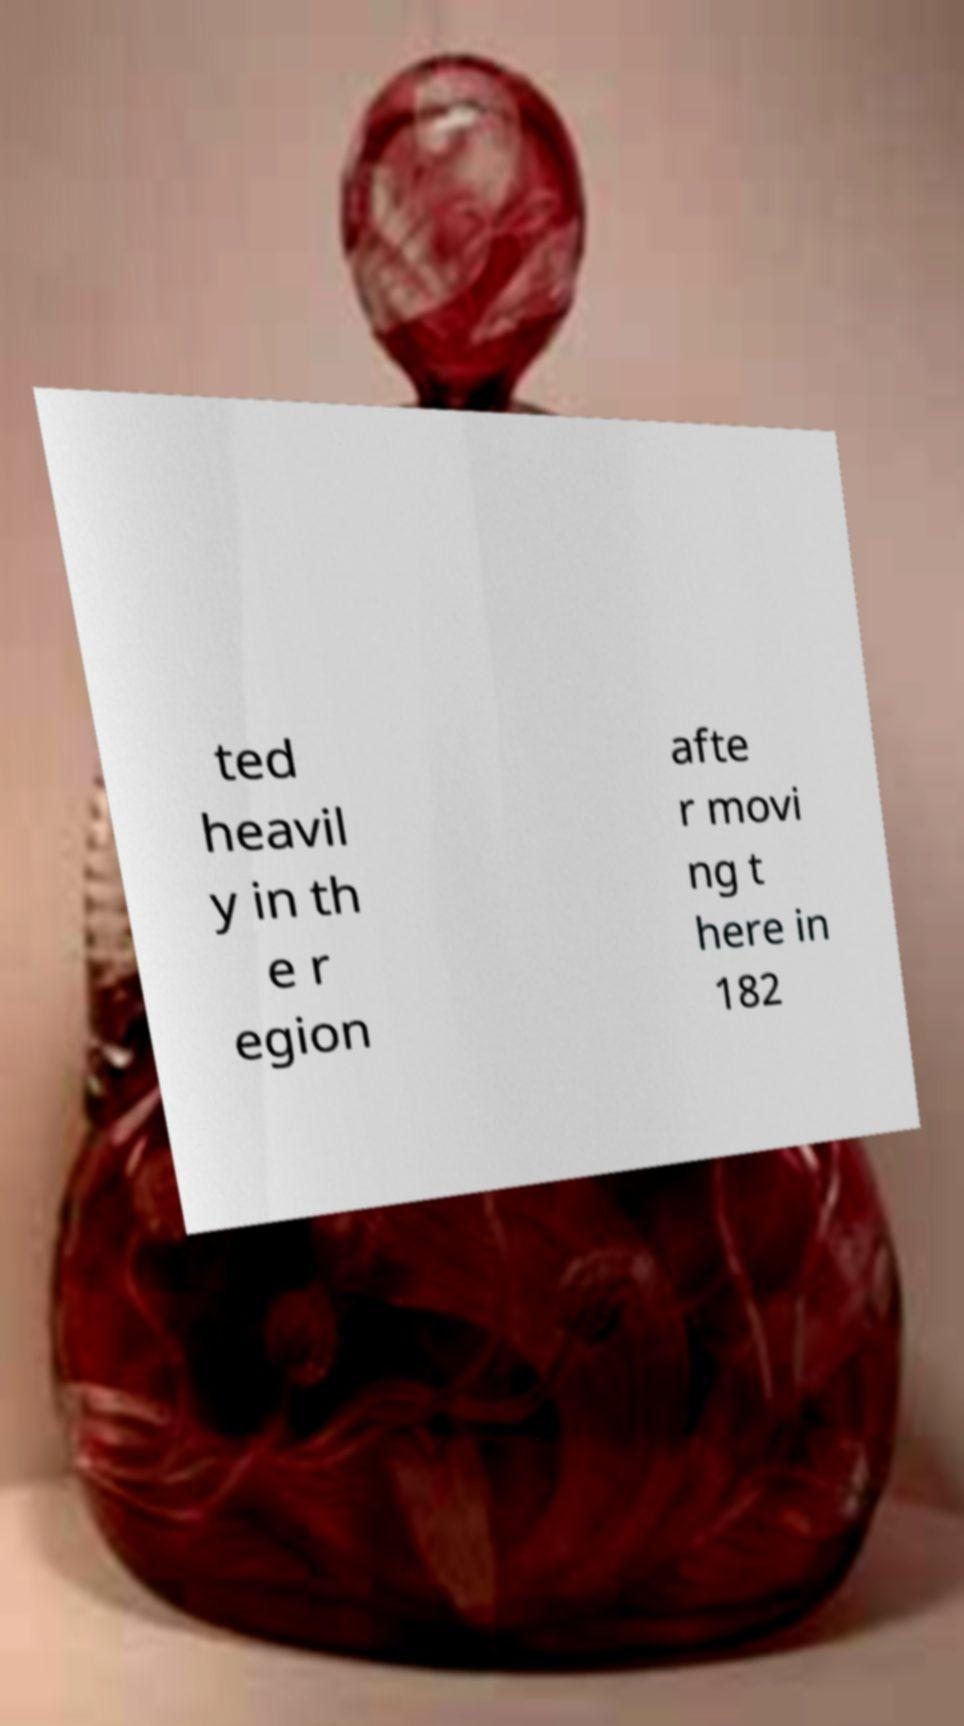What messages or text are displayed in this image? I need them in a readable, typed format. ted heavil y in th e r egion afte r movi ng t here in 182 